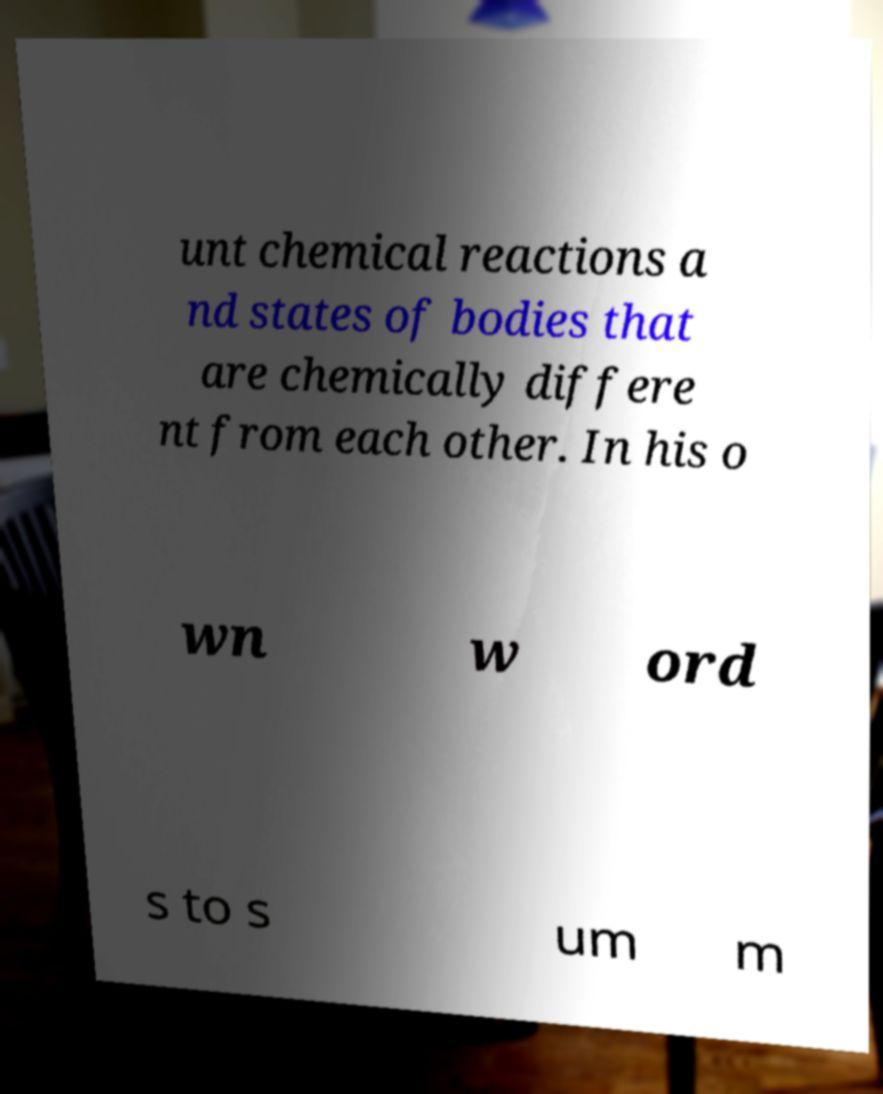Please identify and transcribe the text found in this image. unt chemical reactions a nd states of bodies that are chemically differe nt from each other. In his o wn w ord s to s um m 